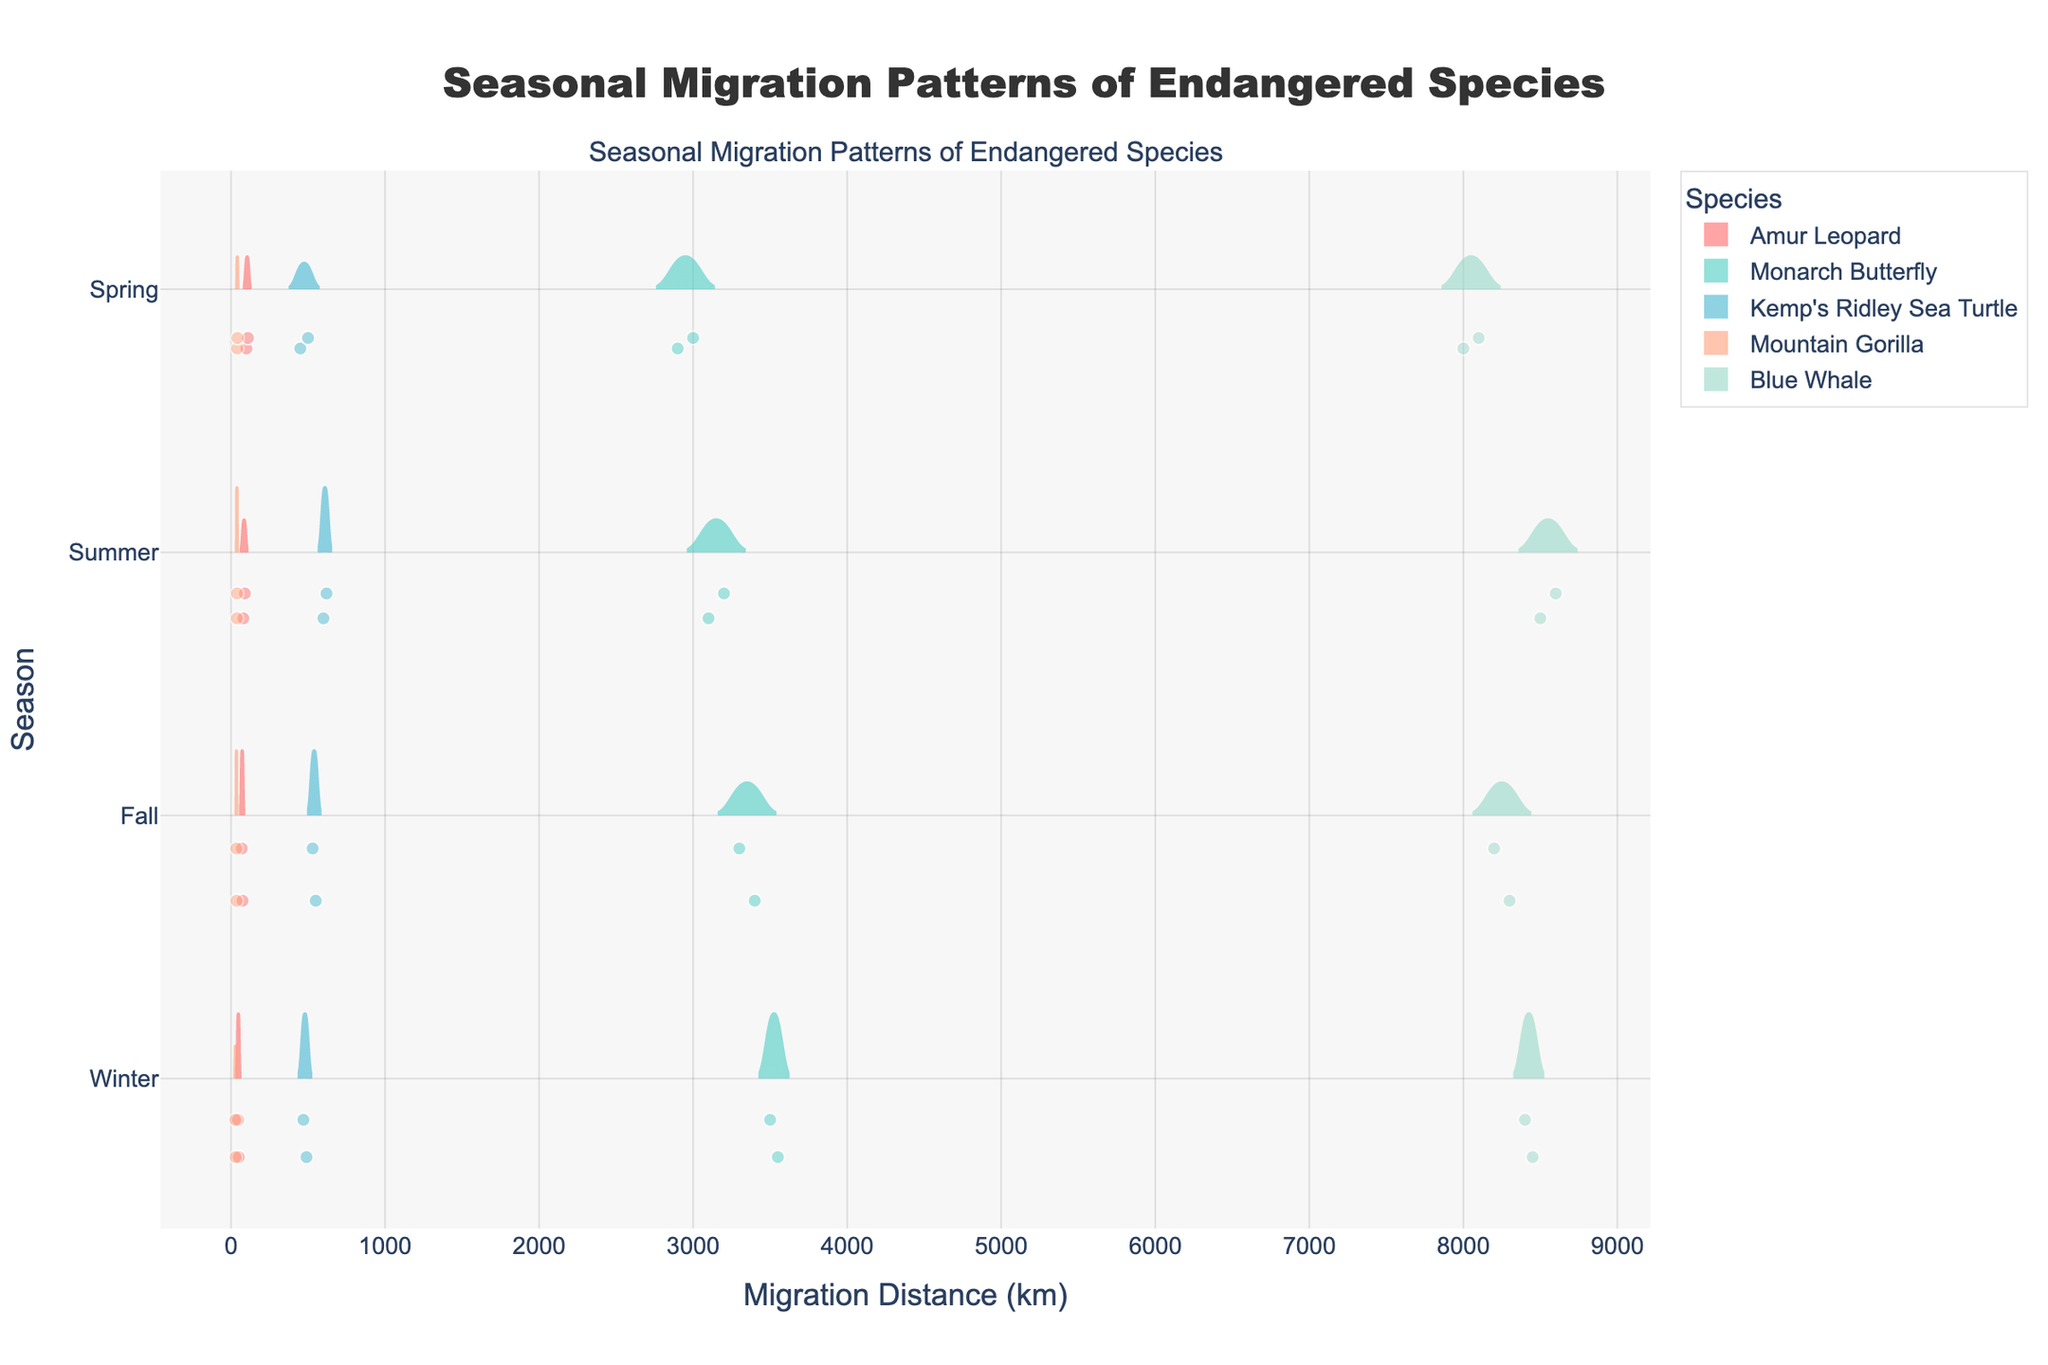What is the title of the figure? The title is typically found at the top of the figure. It summarizes the overall subject of the graph, which in this case is given as 'Seasonal Migration Patterns of Endangered Species'.
Answer: Seasonal Migration Patterns of Endangered Species What is the x-axis representing? The x-axis title is given and it states 'Migration Distance (km)', which means it represents the distance over which the species migrate, measured in kilometers.
Answer: Migration Distance (km) Which species has the largest migration distance, and in which season does it occur? Observing the horizontal violin plots, the Blue Whale has the longest migration distance, as it reaches around 8600 km during the Summer.
Answer: Blue Whale, Summer For which season does the Amur Leopard have the smallest range in migration distances? By looking at the spread of the data points in the violin plots for each season, the Amur Leopard shows the smallest range in migration distance during the Winter.
Answer: Winter Between the Monarch Butterfly and the Blue Whale, which has a wider range of migration distances in the Summer? By comparing the widths of the violin plots for the Summer season, we observe that the Monarch Butterfly has a range of about 3100 to 3200 km, while the Blue Whale has a range of about 8500 to 8600 km. Both ranges are around 100 km, therefore they have equivalent ranges in this season.
Answer: Equivalent ranges in the Summer What is the approximate average migration distance for the Mountain Gorilla in Spring? The violin plot for the Mountain Gorilla in Spring shows distances at around 40 and 42 km. The average of these two values can be calculated as (40 + 42) / 2 = 41 km.
Answer: 41 km Which species shows the most significant seasonal variation in migration distance? By examining the spread and difference of their migration distances across seasons in the violin plots, the Blue Whale shows the most significant variation, with distances ranging from around 8000 km in Spring to 8600 km in Summer.
Answer: Blue Whale How many data points are present for Winter season for Kemp's Ridley Sea Turtle? Each data point is represented by a small marker on the violin plot, specifically for the Winter season for Kemp’s Ridley Sea Turtle, counting these markers gives 2 data points.
Answer: 2 What is the distribution shape for the Monarch Butterfly’s migration distance in Winter? Observing the violin plot for the Monarch Butterfly during Winter, the distribution appears slightly positively skewed with most data points clustered around 3550 km, but also stretching down to 3500 km.
Answer: Positively skewed Which season shows the closest average migration distances across all species? By comparing the central tendencies represented by the mean lines in each violin plot across seasons, Winter appears to have relatively closer averages across the species where Amur Leopard shows around 47.5 km, Monarch Butterfly around 3525 km, Kemp’s Ridley Sea Turtle around 480 km, Mountain Gorilla around 29 km, Blue Whale around 8425 km. These center points show less variation in comparison to other seasons.
Answer: Winter 